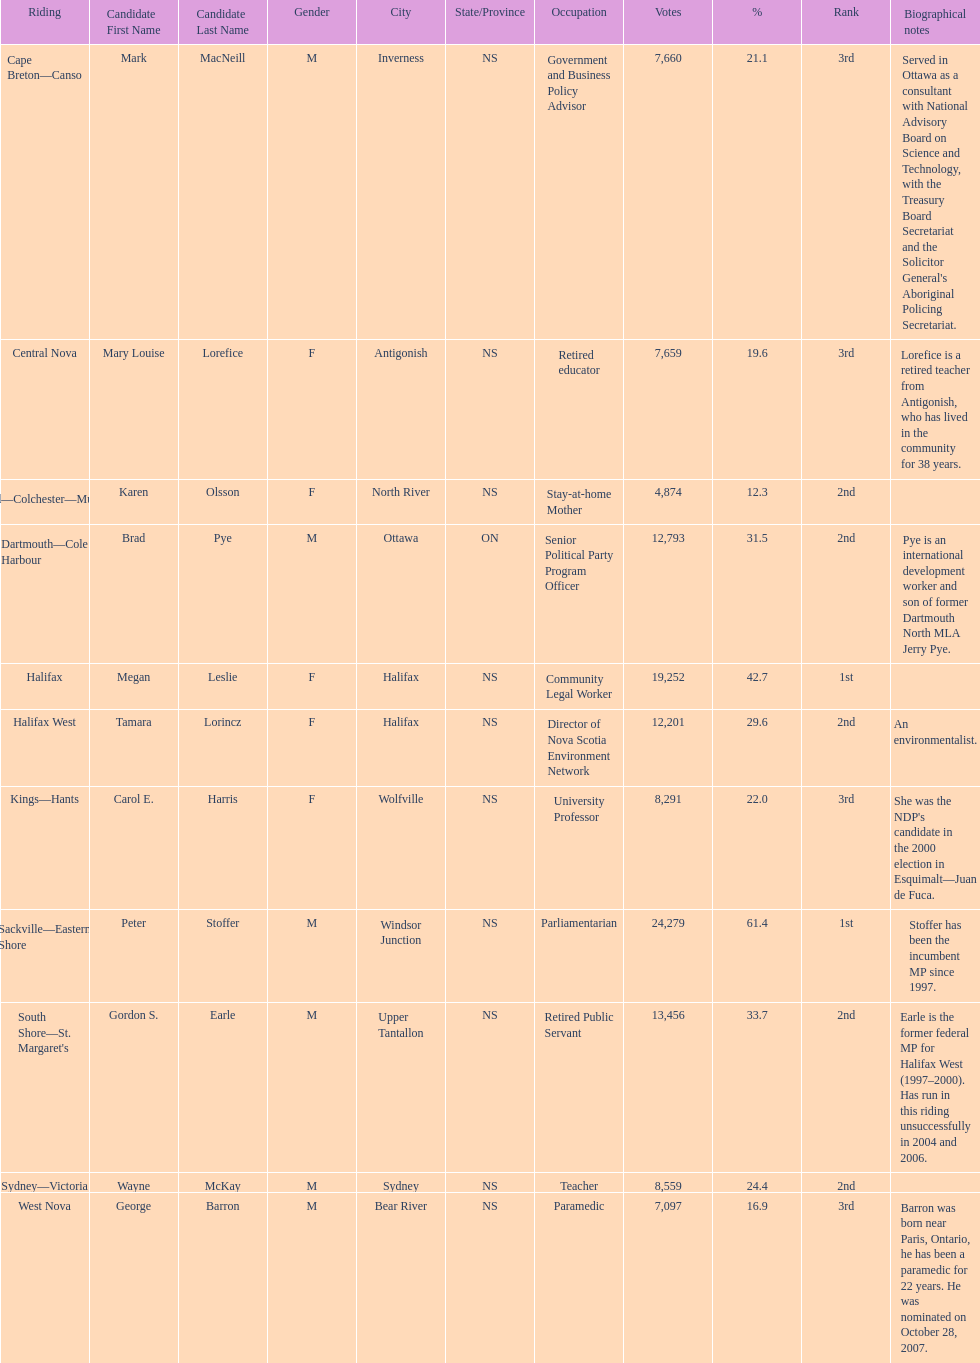How many of the candidates were females? 5. 